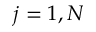Convert formula to latex. <formula><loc_0><loc_0><loc_500><loc_500>j = 1 , N</formula> 